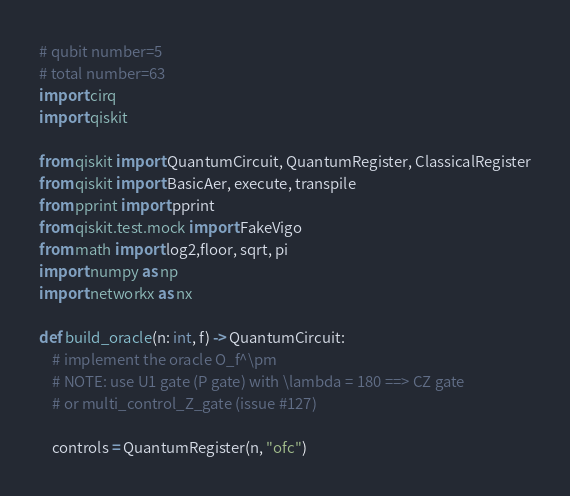Convert code to text. <code><loc_0><loc_0><loc_500><loc_500><_Python_># qubit number=5
# total number=63
import cirq
import qiskit

from qiskit import QuantumCircuit, QuantumRegister, ClassicalRegister
from qiskit import BasicAer, execute, transpile
from pprint import pprint
from qiskit.test.mock import FakeVigo
from math import log2,floor, sqrt, pi
import numpy as np
import networkx as nx

def build_oracle(n: int, f) -> QuantumCircuit:
    # implement the oracle O_f^\pm
    # NOTE: use U1 gate (P gate) with \lambda = 180 ==> CZ gate
    # or multi_control_Z_gate (issue #127)

    controls = QuantumRegister(n, "ofc")</code> 